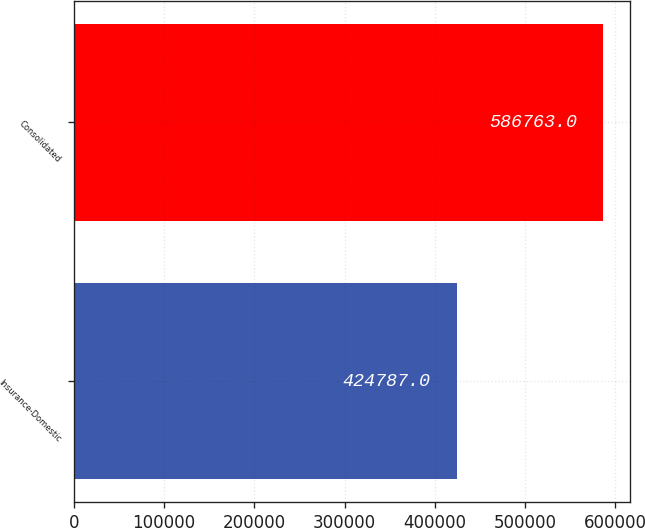<chart> <loc_0><loc_0><loc_500><loc_500><bar_chart><fcel>Insurance-Domestic<fcel>Consolidated<nl><fcel>424787<fcel>586763<nl></chart> 